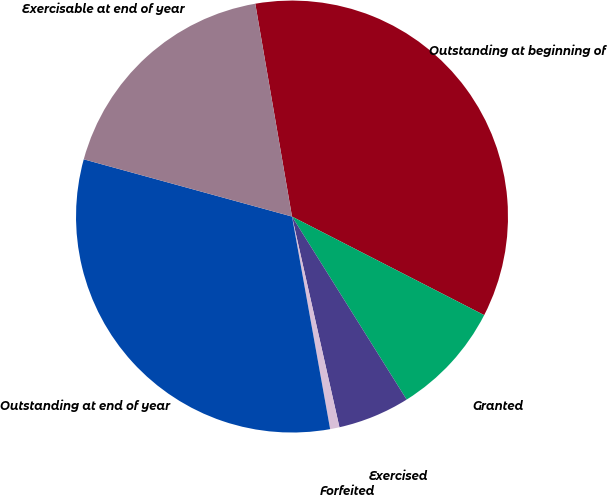<chart> <loc_0><loc_0><loc_500><loc_500><pie_chart><fcel>Outstanding at beginning of<fcel>Granted<fcel>Exercised<fcel>Forfeited<fcel>Outstanding at end of year<fcel>Exercisable at end of year<nl><fcel>35.26%<fcel>8.55%<fcel>5.38%<fcel>0.7%<fcel>32.09%<fcel>18.01%<nl></chart> 